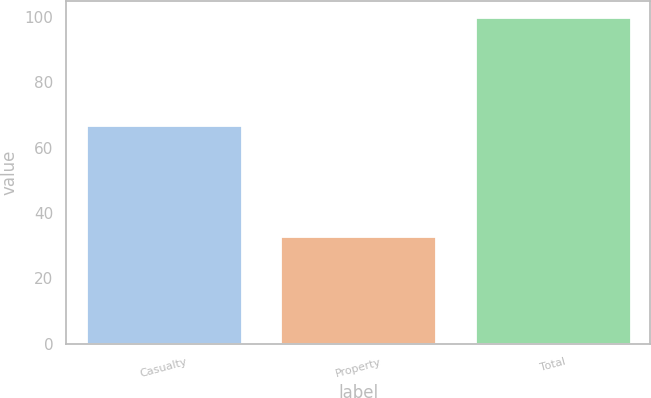Convert chart to OTSL. <chart><loc_0><loc_0><loc_500><loc_500><bar_chart><fcel>Casualty<fcel>Property<fcel>Total<nl><fcel>66.9<fcel>33.1<fcel>100<nl></chart> 